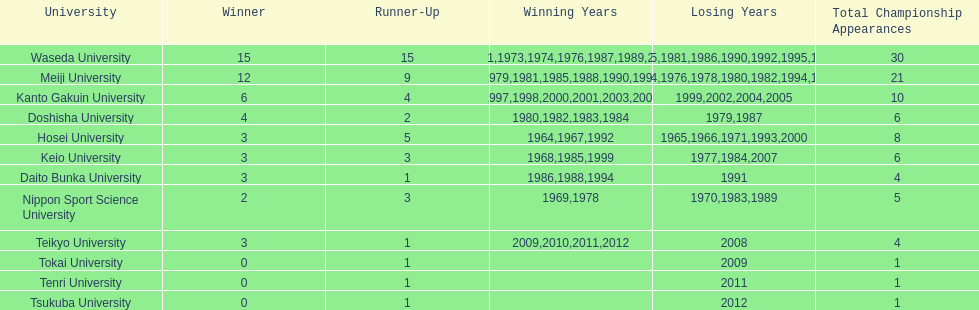Who won the last championship recorded on this table? Teikyo University. 